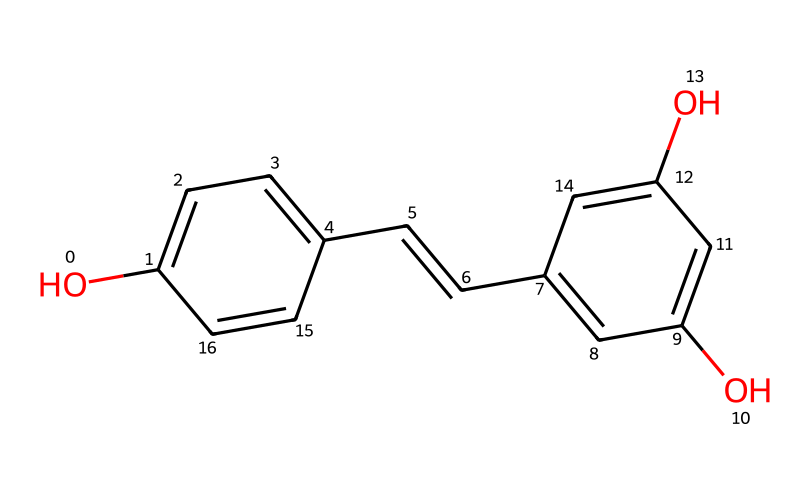How many hydroxyl groups are present in this chemical? The SMILES notation indicates the presence of two 'O' atoms in the structure before the 'c', which correspond to hydroxyl (-OH) groups. Both the indicated 'O' in the structure represent hydroxyls, confirming the count.
Answer: two What is the maximum number of aromatic rings in this structure? The structure includes two connected aromatic segments; each 'c' in the SMILES represents a carbon atom involved in the aromatic system. The 'c' rings connected by the double bond indicate that there are two distinct aromatic rings.
Answer: two How many double bonds exist in this molecule? By examining the SMILES representation, we can see one double bond represented by the '/C=C/', confirming that there is one double bond in the structure overall.
Answer: one What type of compound is resveratrol classified as? Resveratrol is classified as a polyphenol, which is indicated by the presence of multiple hydroxyl groups and the aromatic nature of the structure.
Answer: polyphenol What functional groups are present in resveratrol? In the structure, the hydroxyl groups (-OH) and conjugated double bond characterize this compound; thus, the functional groups identified in resveratrol are phenolic groups and alkene.
Answer: phenolic and alkene Is resveratrol soluble in water? Due to the presence of hydroxyl groups that can form hydrogen bonds with water, resveratrol demonstrates some degree of solubility in water.
Answer: yes 